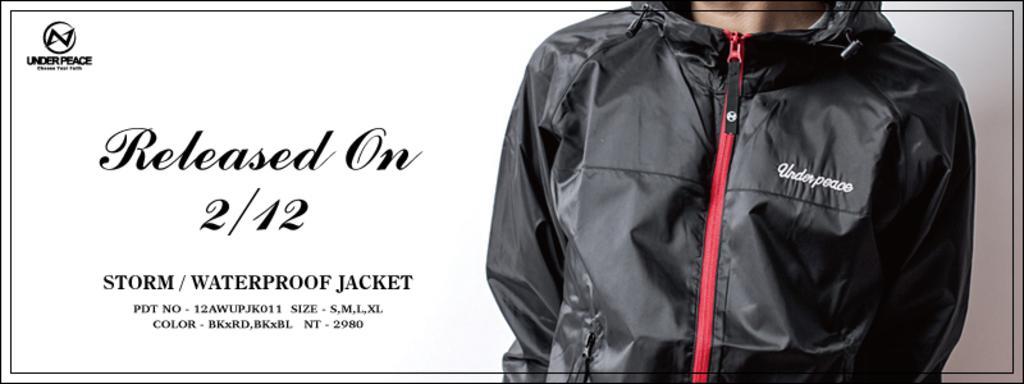Can you describe this image briefly? In this image I can see the person wearing the black color jacket and I can see the name under peace is written on it. To the left there is a text written. And there is a white background. 